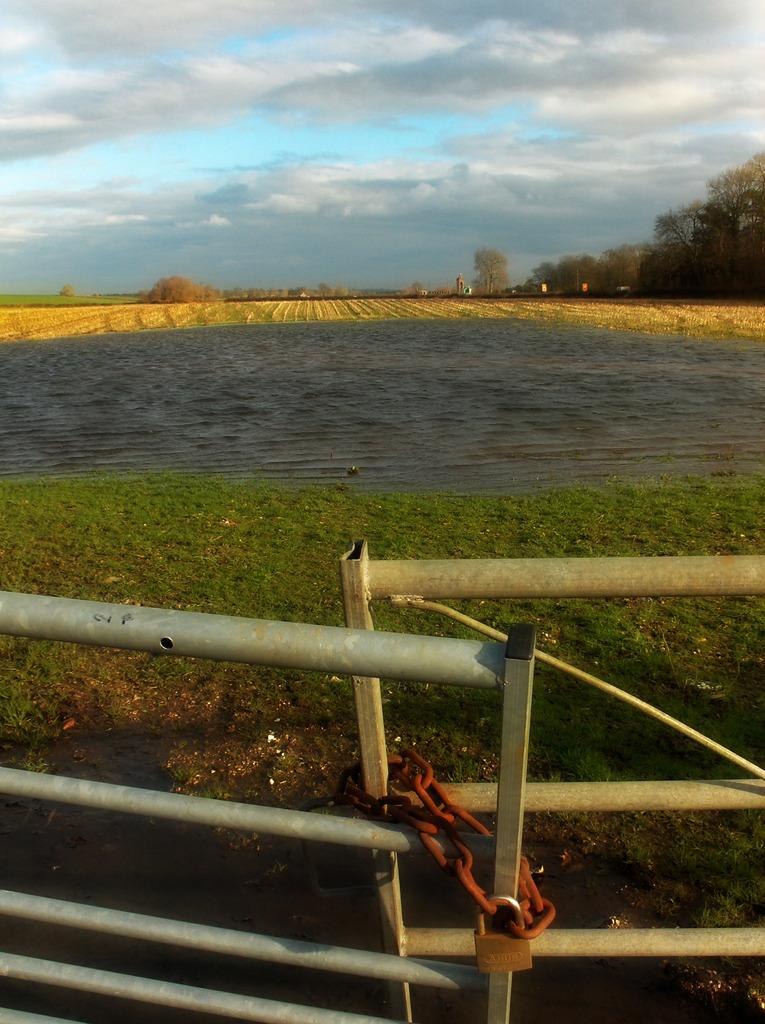What type of landscape is depicted in the image? There is grassland in the image. What is located at the bottom side of the image? There is a boundary at the bottom side of the image. What can be seen in the center of the image? There is water in the center of the image. What type of vegetation is on the right side of the image? There are trees on the right side of the image. What type of creature is sitting on the wren in the image? There is no wren or creature present in the image. How many houses can be seen in the image? There are no houses visible in the image. 